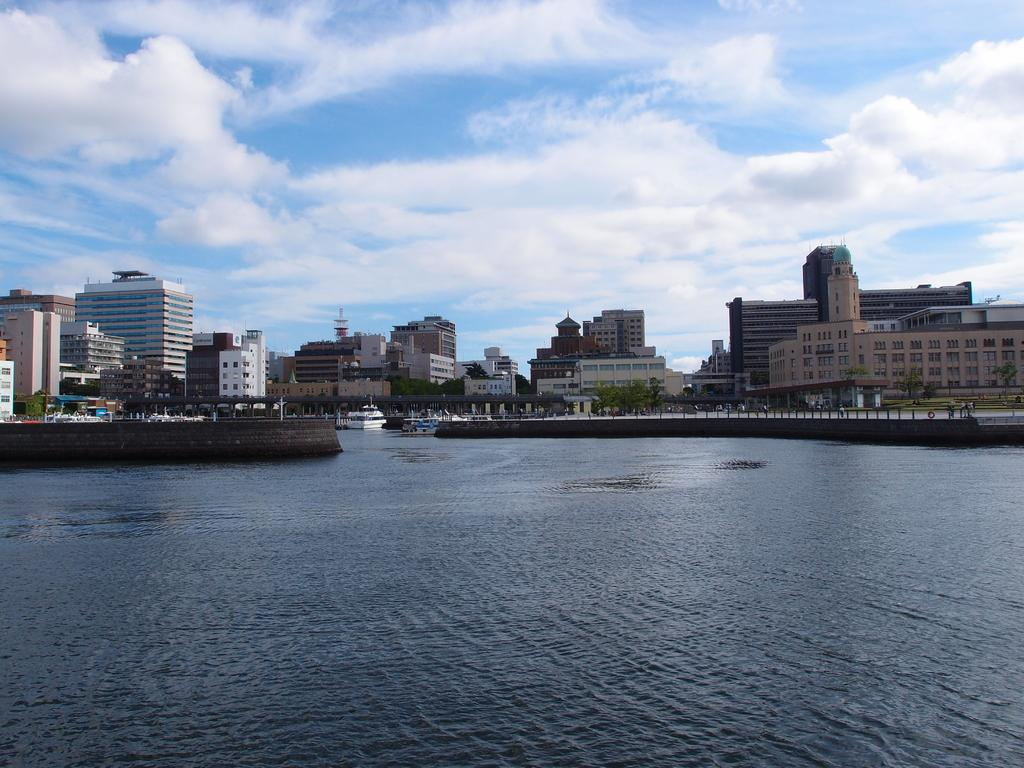What is the main element in the image? There is water in the image. What is floating on the water? There are boats in the water. What can be seen in the distance in the image? There are buildings in the background of the image. What type of vegetation is visible in the image? There are trees visible in the image. What is visible at the top of the image? The sky is visible at the top of the image. What type of trousers are the boats wearing in the image? Boats do not wear trousers, as they are inanimate objects. 